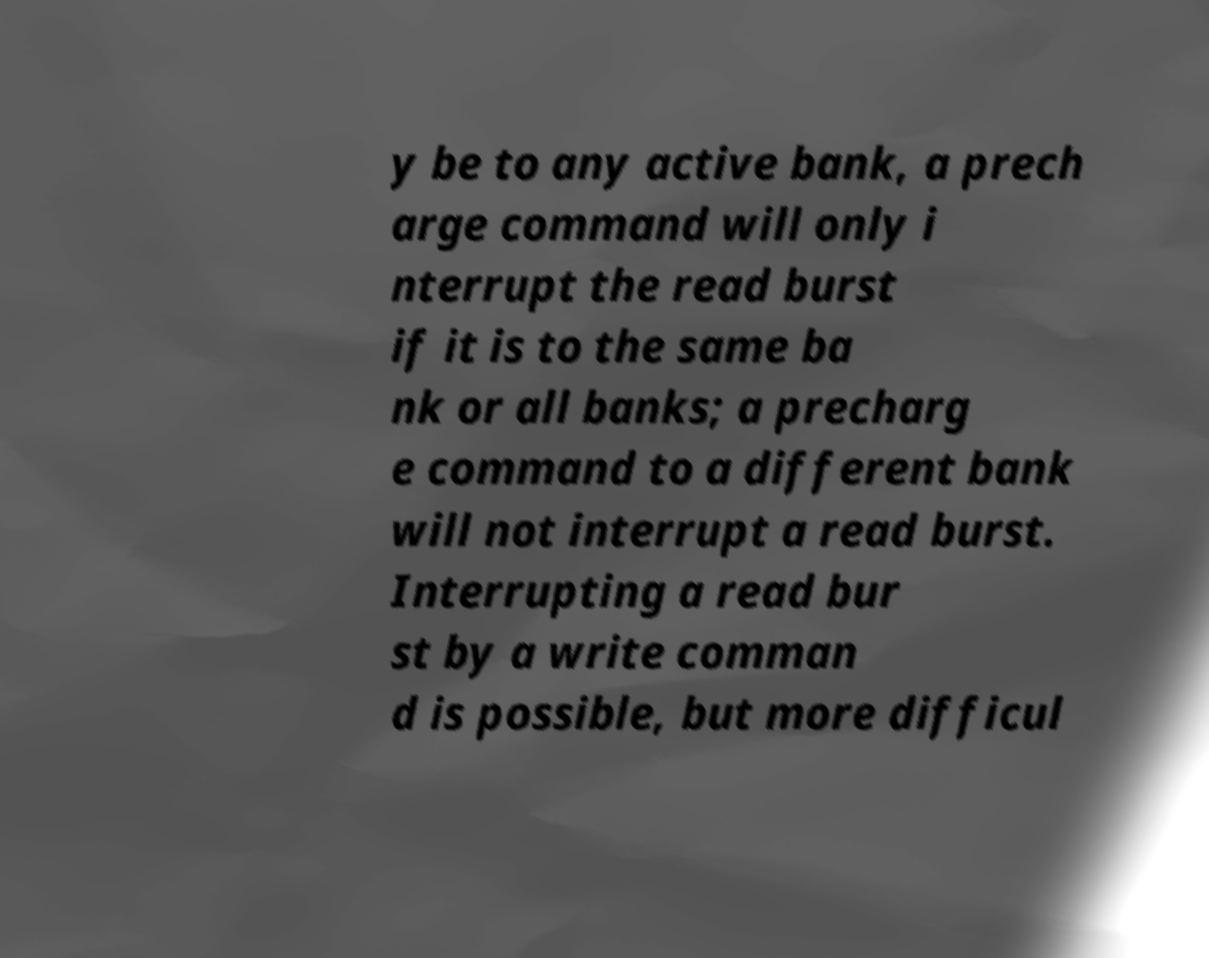Could you assist in decoding the text presented in this image and type it out clearly? y be to any active bank, a prech arge command will only i nterrupt the read burst if it is to the same ba nk or all banks; a precharg e command to a different bank will not interrupt a read burst. Interrupting a read bur st by a write comman d is possible, but more difficul 